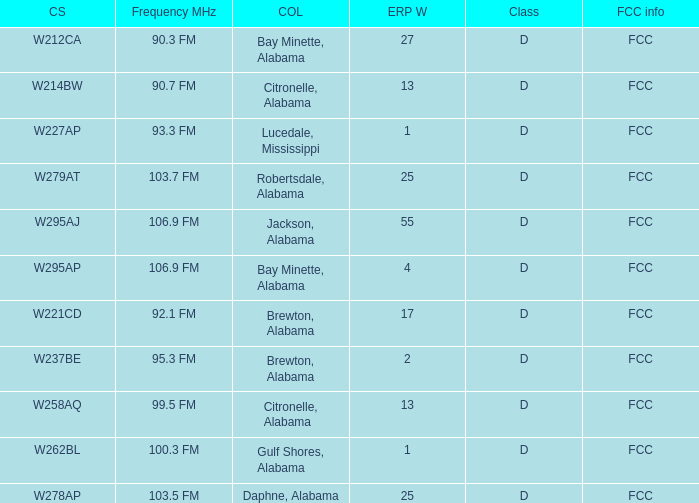Provide the fcc details for the call sign w279at. FCC. 